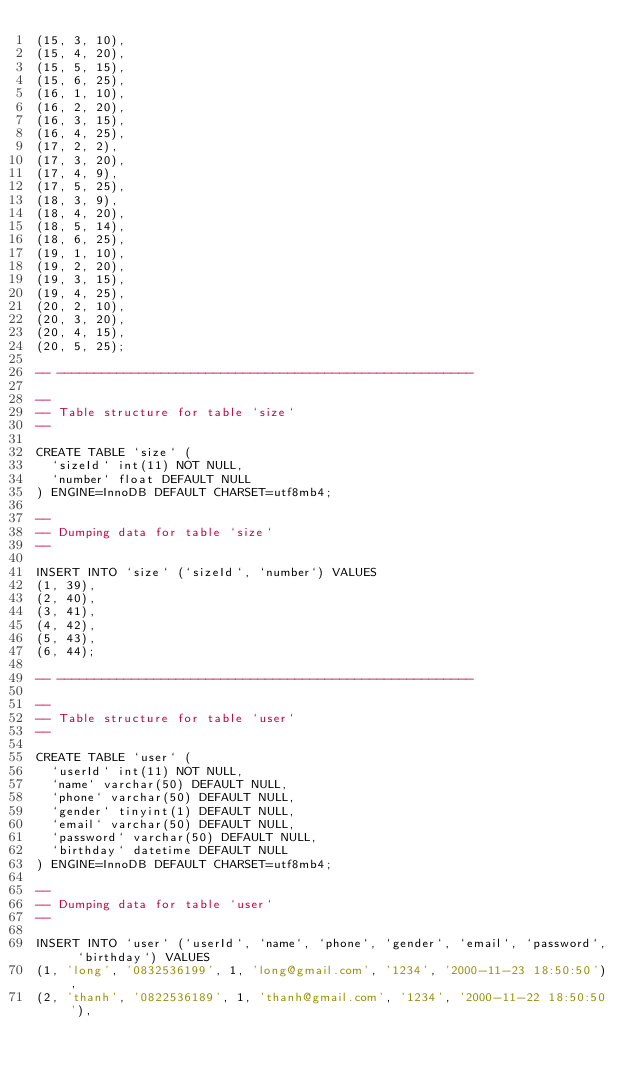<code> <loc_0><loc_0><loc_500><loc_500><_SQL_>(15, 3, 10),
(15, 4, 20),
(15, 5, 15),
(15, 6, 25),
(16, 1, 10),
(16, 2, 20),
(16, 3, 15),
(16, 4, 25),
(17, 2, 2),
(17, 3, 20),
(17, 4, 9),
(17, 5, 25),
(18, 3, 9),
(18, 4, 20),
(18, 5, 14),
(18, 6, 25),
(19, 1, 10),
(19, 2, 20),
(19, 3, 15),
(19, 4, 25),
(20, 2, 10),
(20, 3, 20),
(20, 4, 15),
(20, 5, 25);

-- --------------------------------------------------------

--
-- Table structure for table `size`
--

CREATE TABLE `size` (
  `sizeId` int(11) NOT NULL,
  `number` float DEFAULT NULL
) ENGINE=InnoDB DEFAULT CHARSET=utf8mb4;

--
-- Dumping data for table `size`
--

INSERT INTO `size` (`sizeId`, `number`) VALUES
(1, 39),
(2, 40),
(3, 41),
(4, 42),
(5, 43),
(6, 44);

-- --------------------------------------------------------

--
-- Table structure for table `user`
--

CREATE TABLE `user` (
  `userId` int(11) NOT NULL,
  `name` varchar(50) DEFAULT NULL,
  `phone` varchar(50) DEFAULT NULL,
  `gender` tinyint(1) DEFAULT NULL,
  `email` varchar(50) DEFAULT NULL,
  `password` varchar(50) DEFAULT NULL,
  `birthday` datetime DEFAULT NULL
) ENGINE=InnoDB DEFAULT CHARSET=utf8mb4;

--
-- Dumping data for table `user`
--

INSERT INTO `user` (`userId`, `name`, `phone`, `gender`, `email`, `password`, `birthday`) VALUES
(1, 'long', '0832536199', 1, 'long@gmail.com', '1234', '2000-11-23 18:50:50'),
(2, 'thanh', '0822536189', 1, 'thanh@gmail.com', '1234', '2000-11-22 18:50:50'),</code> 